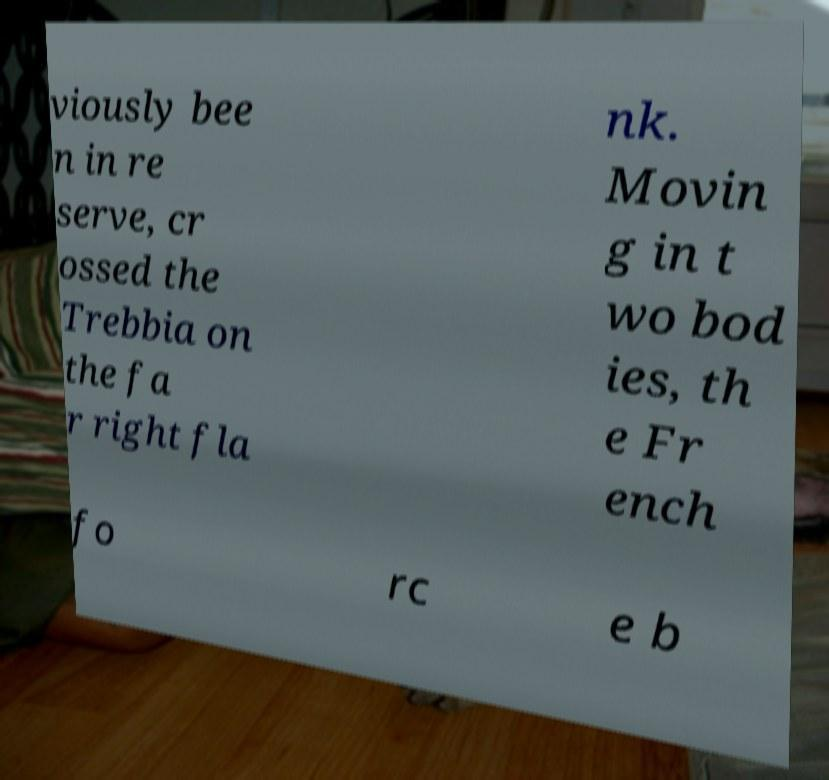Can you accurately transcribe the text from the provided image for me? viously bee n in re serve, cr ossed the Trebbia on the fa r right fla nk. Movin g in t wo bod ies, th e Fr ench fo rc e b 